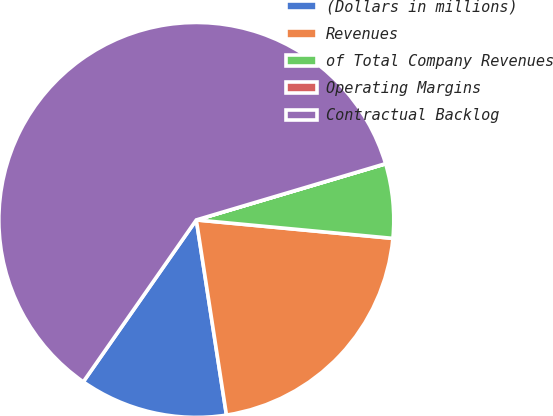Convert chart. <chart><loc_0><loc_0><loc_500><loc_500><pie_chart><fcel>(Dollars in millions)<fcel>Revenues<fcel>of Total Company Revenues<fcel>Operating Margins<fcel>Contractual Backlog<nl><fcel>12.14%<fcel>21.07%<fcel>6.08%<fcel>0.01%<fcel>60.7%<nl></chart> 